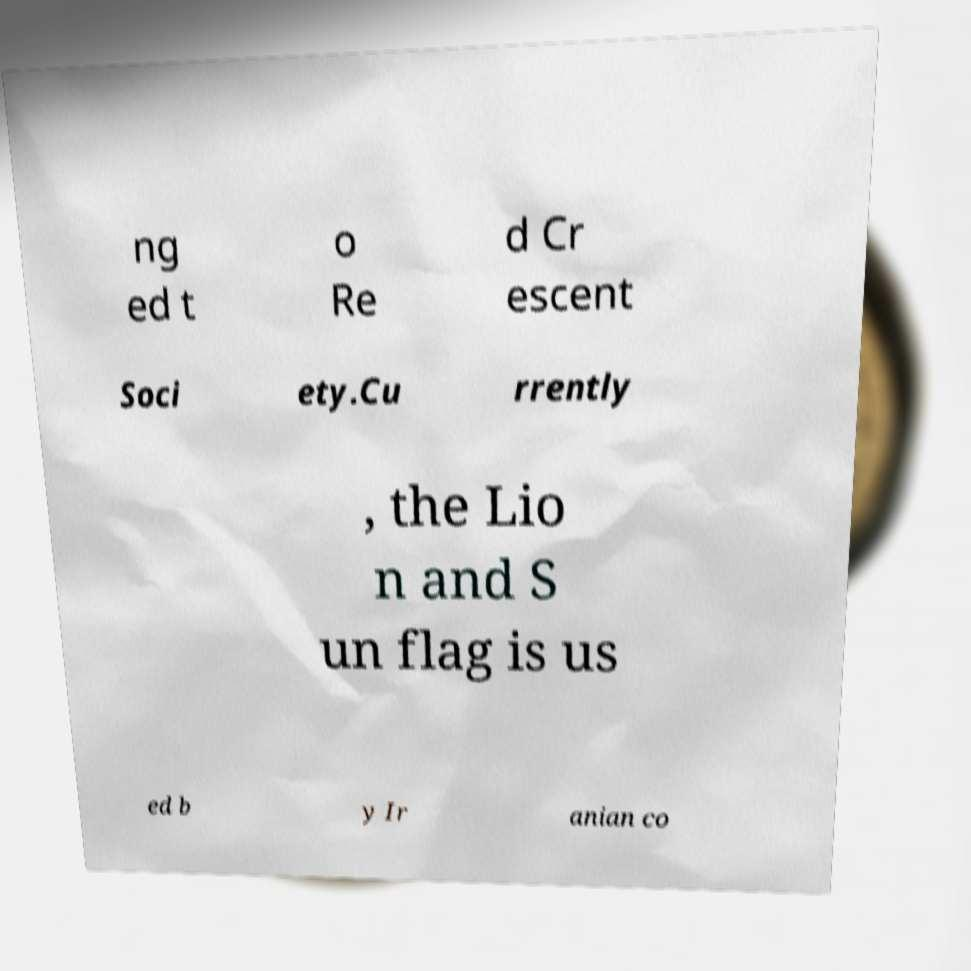Could you extract and type out the text from this image? ng ed t o Re d Cr escent Soci ety.Cu rrently , the Lio n and S un flag is us ed b y Ir anian co 